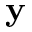<formula> <loc_0><loc_0><loc_500><loc_500>\mathbf y</formula> 